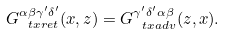Convert formula to latex. <formula><loc_0><loc_0><loc_500><loc_500>G _ { \ t x { r e t } } ^ { \alpha \beta \gamma ^ { \prime } \delta ^ { \prime } } ( x , z ) = G _ { \ t x { a d v } } ^ { \gamma ^ { \prime } \delta ^ { \prime } \alpha \beta } ( z , x ) .</formula> 